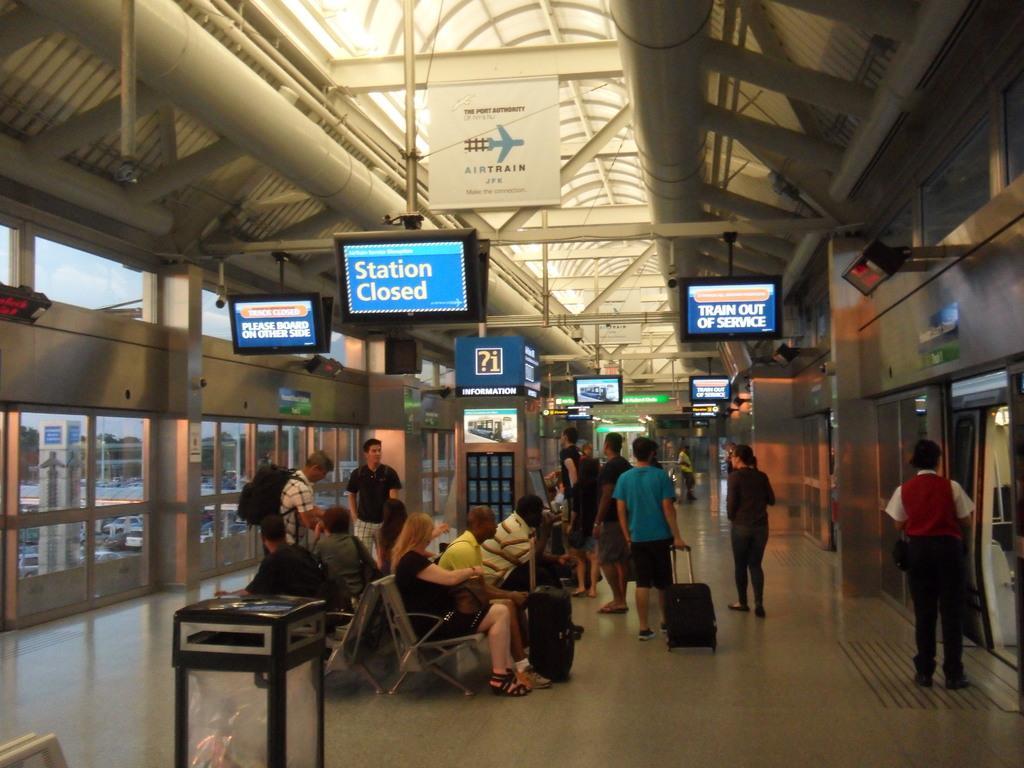In one or two sentences, can you explain what this image depicts? In the image there are few people sitting on the bench and other few people standing. There are luggage bags. And also there are screen hanging to the rods. At the top of the image there is a ceiling with rods and also there is a poster. On the left side of the image to the wall there are glass doors. And on the right of the image there are glass doors and a screen. 